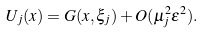Convert formula to latex. <formula><loc_0><loc_0><loc_500><loc_500>U _ { j } ( x ) = G ( x , \xi _ { j } ) + O ( \mu _ { j } ^ { 2 } \varepsilon ^ { 2 } ) .</formula> 